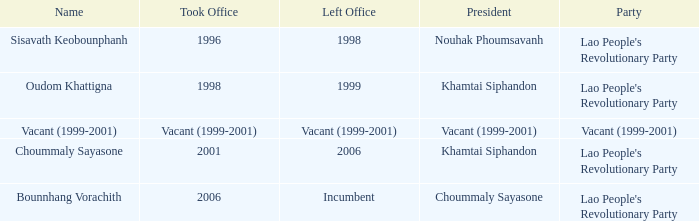I'm looking to parse the entire table for insights. Could you assist me with that? {'header': ['Name', 'Took Office', 'Left Office', 'President', 'Party'], 'rows': [['Sisavath Keobounphanh', '1996', '1998', 'Nouhak Phoumsavanh', "Lao People's Revolutionary Party"], ['Oudom Khattigna', '1998', '1999', 'Khamtai Siphandon', "Lao People's Revolutionary Party"], ['Vacant (1999-2001)', 'Vacant (1999-2001)', 'Vacant (1999-2001)', 'Vacant (1999-2001)', 'Vacant (1999-2001)'], ['Choummaly Sayasone', '2001', '2006', 'Khamtai Siphandon', "Lao People's Revolutionary Party"], ['Bounnhang Vorachith', '2006', 'Incumbent', 'Choummaly Sayasone', "Lao People's Revolutionary Party"]]} In 1998, what party did the individual belong to when they assumed office? Lao People's Revolutionary Party. 